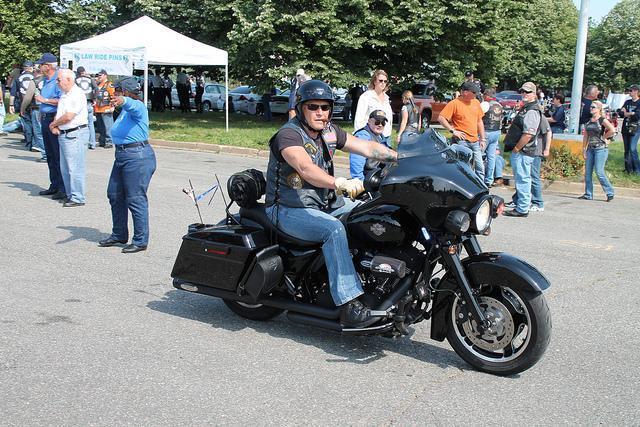How many riders are on the black motorcycle?
Give a very brief answer. 1. How many policeman are pictured?
Give a very brief answer. 0. How many people are in the picture?
Give a very brief answer. 7. 